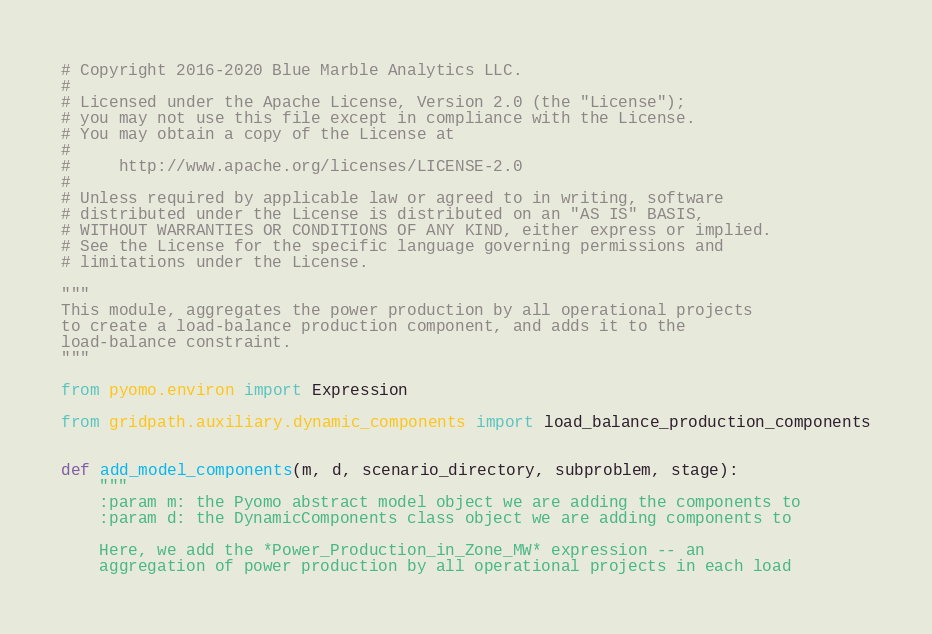<code> <loc_0><loc_0><loc_500><loc_500><_Python_># Copyright 2016-2020 Blue Marble Analytics LLC.
#
# Licensed under the Apache License, Version 2.0 (the "License");
# you may not use this file except in compliance with the License.
# You may obtain a copy of the License at
#
#     http://www.apache.org/licenses/LICENSE-2.0
#
# Unless required by applicable law or agreed to in writing, software
# distributed under the License is distributed on an "AS IS" BASIS,
# WITHOUT WARRANTIES OR CONDITIONS OF ANY KIND, either express or implied.
# See the License for the specific language governing permissions and
# limitations under the License.

"""
This module, aggregates the power production by all operational projects
to create a load-balance production component, and adds it to the
load-balance constraint.
"""

from pyomo.environ import Expression

from gridpath.auxiliary.dynamic_components import load_balance_production_components


def add_model_components(m, d, scenario_directory, subproblem, stage):
    """
    :param m: the Pyomo abstract model object we are adding the components to
    :param d: the DynamicComponents class object we are adding components to

    Here, we add the *Power_Production_in_Zone_MW* expression -- an
    aggregation of power production by all operational projects in each load</code> 